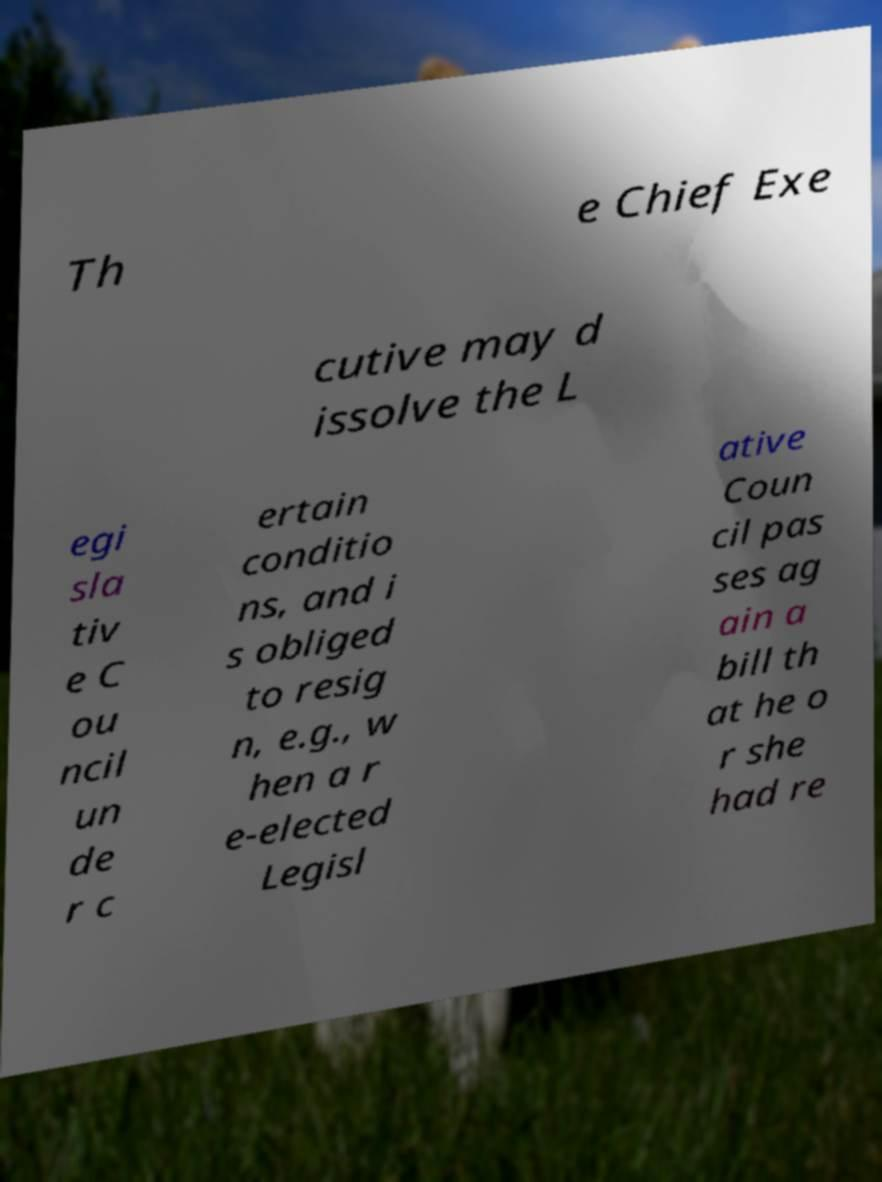There's text embedded in this image that I need extracted. Can you transcribe it verbatim? Th e Chief Exe cutive may d issolve the L egi sla tiv e C ou ncil un de r c ertain conditio ns, and i s obliged to resig n, e.g., w hen a r e-elected Legisl ative Coun cil pas ses ag ain a bill th at he o r she had re 